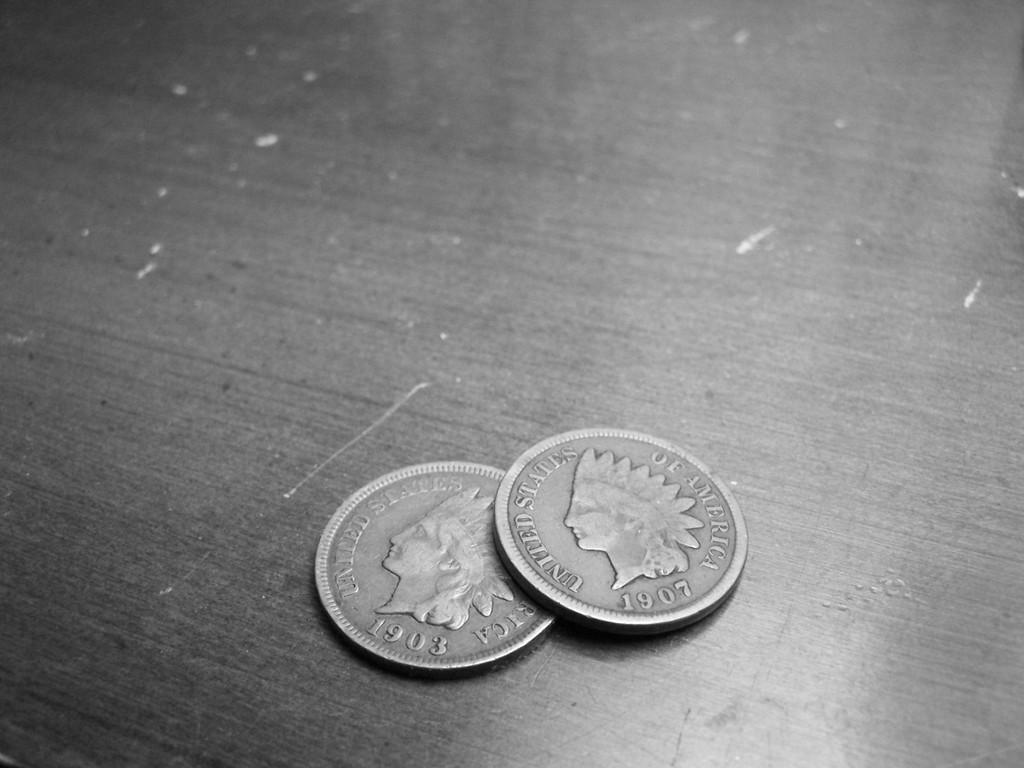Provide a one-sentence caption for the provided image. Two United States Indian head pennies from 1903 and 1907. 